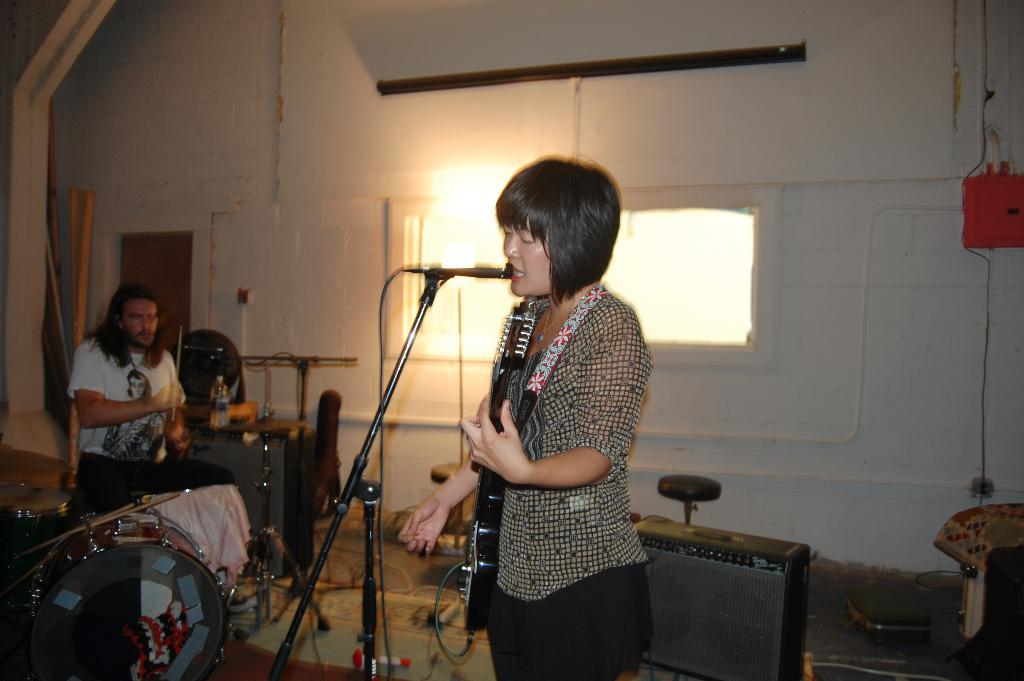How many people are in the room? There are two people in the room. Can you describe the girl in the room? The girl is holding a musical instrument and standing in front of a microphone. What is the other person in the room doing? The other person is holding a musical instrument. What type of airplane can be seen in the garden outside the room? There is no airplane or garden present in the image; it only shows two people in a room. 